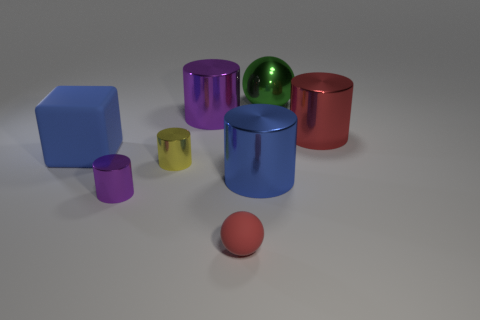There is a cylinder that is the same color as the block; what material is it?
Offer a terse response. Metal. How many objects are either small purple cylinders or metal cylinders that are behind the large blue matte thing?
Make the answer very short. 3. There is a blue object left of the sphere that is left of the large metallic sphere; how many purple things are behind it?
Your answer should be very brief. 1. There is a purple cylinder that is the same size as the metal sphere; what material is it?
Ensure brevity in your answer.  Metal. Is there a blue metal cylinder of the same size as the red matte sphere?
Offer a terse response. No. The large matte thing is what color?
Ensure brevity in your answer.  Blue. What is the color of the ball that is in front of the sphere behind the tiny red ball?
Your response must be concise. Red. What is the shape of the object that is in front of the purple object in front of the blue thing to the right of the big blue rubber thing?
Your answer should be compact. Sphere. How many green objects have the same material as the yellow cylinder?
Offer a very short reply. 1. What number of purple shiny things are behind the big metallic thing on the right side of the large green metallic sphere?
Offer a very short reply. 1. 